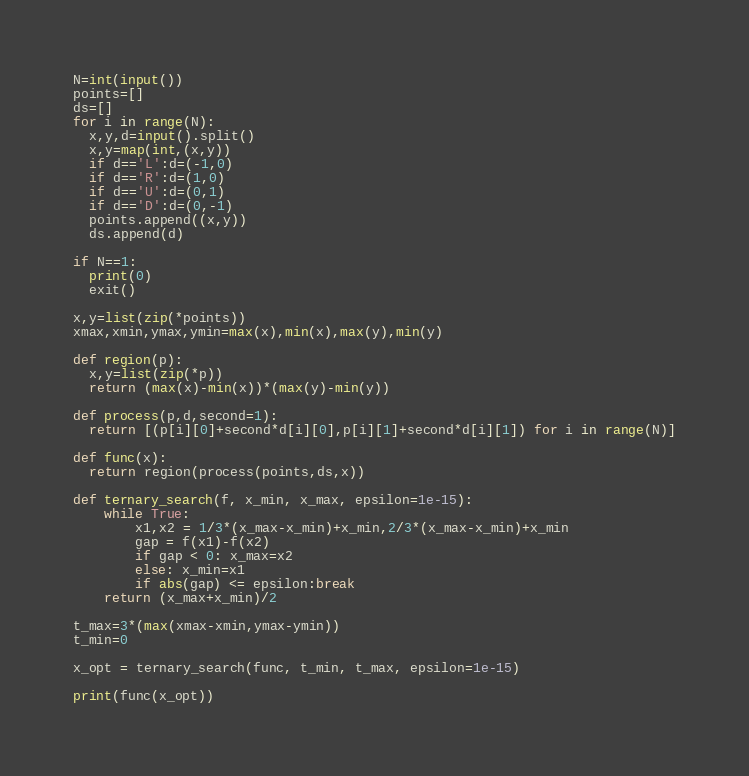Convert code to text. <code><loc_0><loc_0><loc_500><loc_500><_Python_>N=int(input())
points=[]
ds=[]
for i in range(N):
  x,y,d=input().split()
  x,y=map(int,(x,y))
  if d=='L':d=(-1,0)
  if d=='R':d=(1,0)
  if d=='U':d=(0,1)
  if d=='D':d=(0,-1)
  points.append((x,y))
  ds.append(d)

if N==1:
  print(0)
  exit()

x,y=list(zip(*points))
xmax,xmin,ymax,ymin=max(x),min(x),max(y),min(y)

def region(p):
  x,y=list(zip(*p))
  return (max(x)-min(x))*(max(y)-min(y))

def process(p,d,second=1):
  return [(p[i][0]+second*d[i][0],p[i][1]+second*d[i][1]) for i in range(N)]

def func(x):
  return region(process(points,ds,x))

def ternary_search(f, x_min, x_max, epsilon=1e-15):
    while True:
        x1,x2 = 1/3*(x_max-x_min)+x_min,2/3*(x_max-x_min)+x_min
        gap = f(x1)-f(x2)
        if gap < 0: x_max=x2
        else: x_min=x1
        if abs(gap) <= epsilon:break
    return (x_max+x_min)/2
  
t_max=3*(max(xmax-xmin,ymax-ymin))
t_min=0

x_opt = ternary_search(func, t_min, t_max, epsilon=1e-15)

print(func(x_opt))</code> 